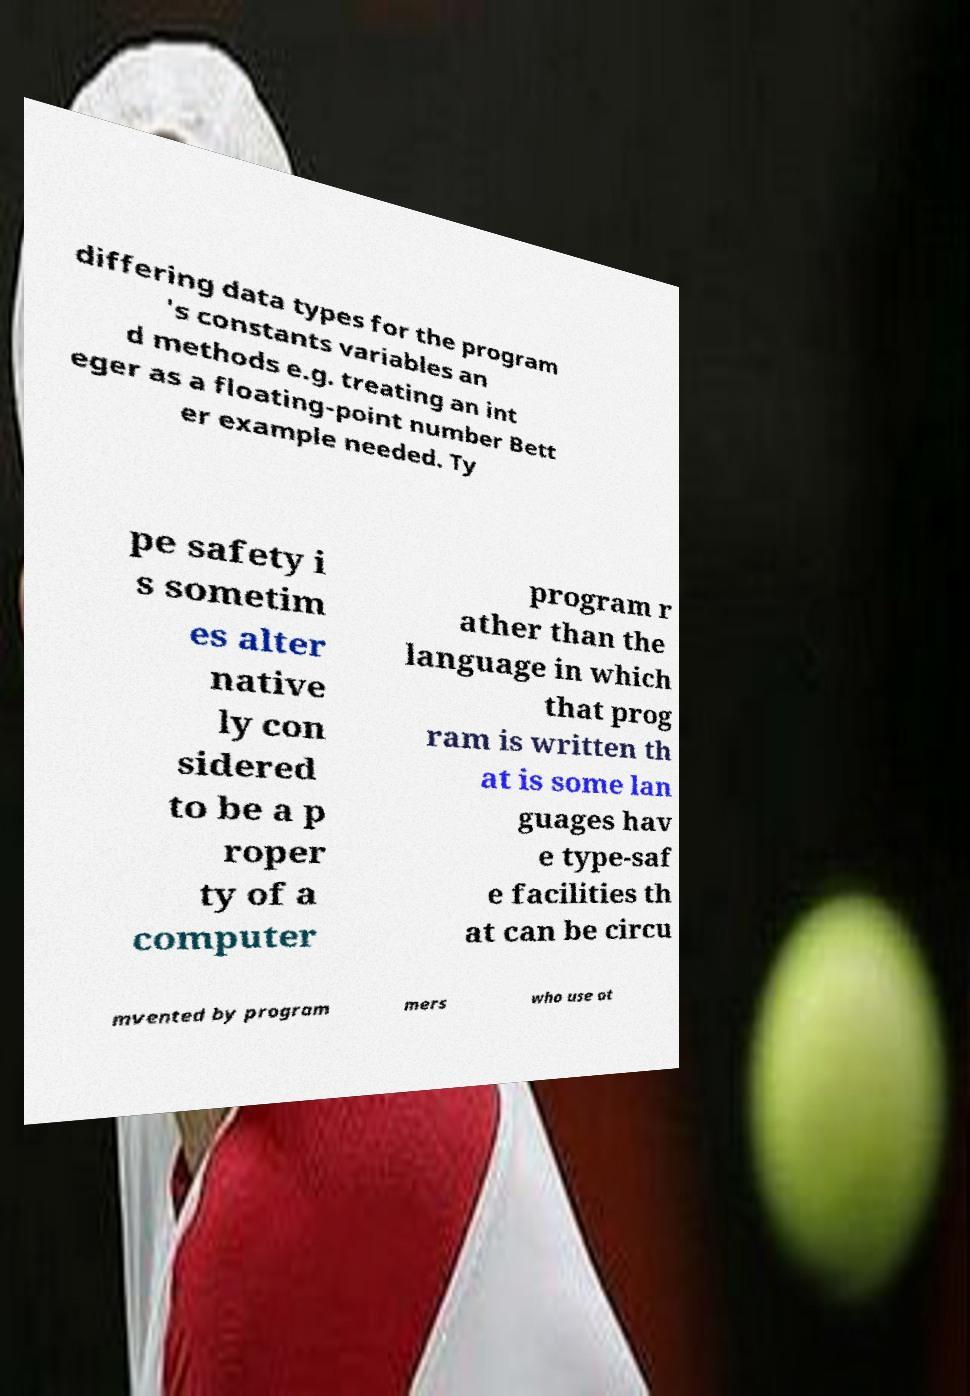Please read and relay the text visible in this image. What does it say? differing data types for the program 's constants variables an d methods e.g. treating an int eger as a floating-point number Bett er example needed. Ty pe safety i s sometim es alter native ly con sidered to be a p roper ty of a computer program r ather than the language in which that prog ram is written th at is some lan guages hav e type-saf e facilities th at can be circu mvented by program mers who use ot 